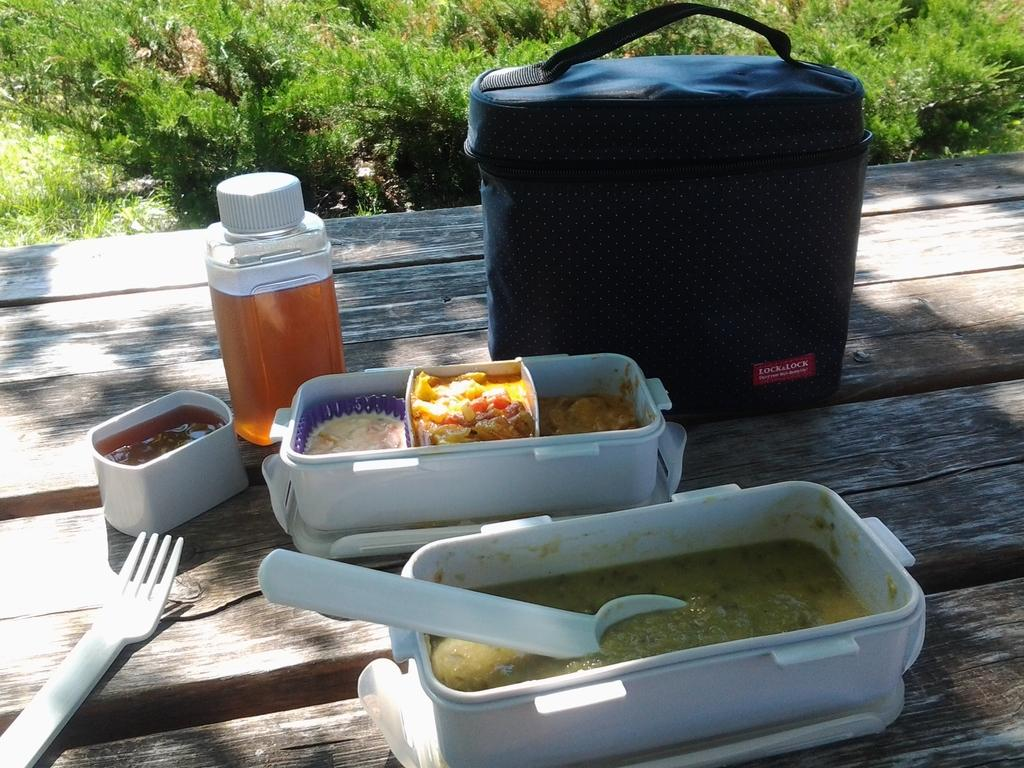<image>
Create a compact narrative representing the image presented. The food contents of a Lock&Lock lunch tote are spread out on the table. 